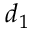Convert formula to latex. <formula><loc_0><loc_0><loc_500><loc_500>d _ { 1 }</formula> 